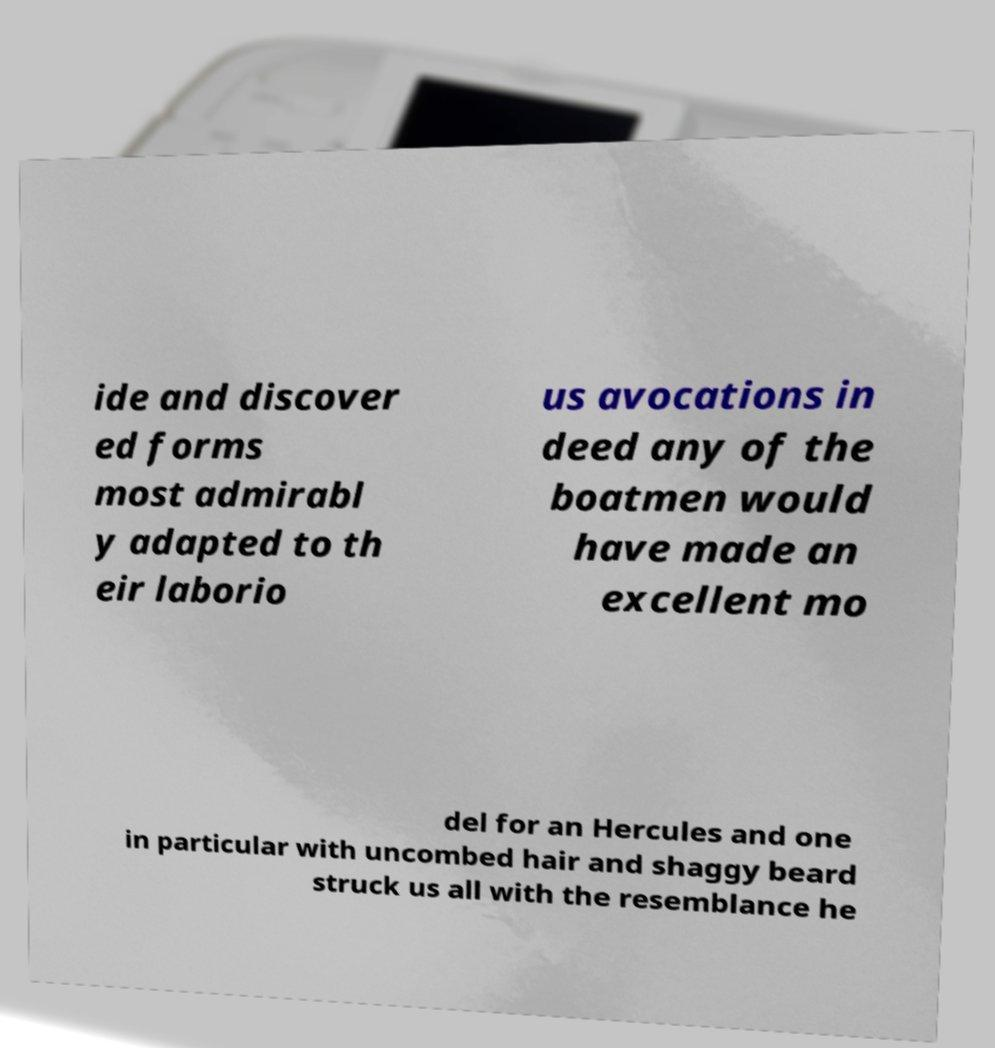There's text embedded in this image that I need extracted. Can you transcribe it verbatim? ide and discover ed forms most admirabl y adapted to th eir laborio us avocations in deed any of the boatmen would have made an excellent mo del for an Hercules and one in particular with uncombed hair and shaggy beard struck us all with the resemblance he 